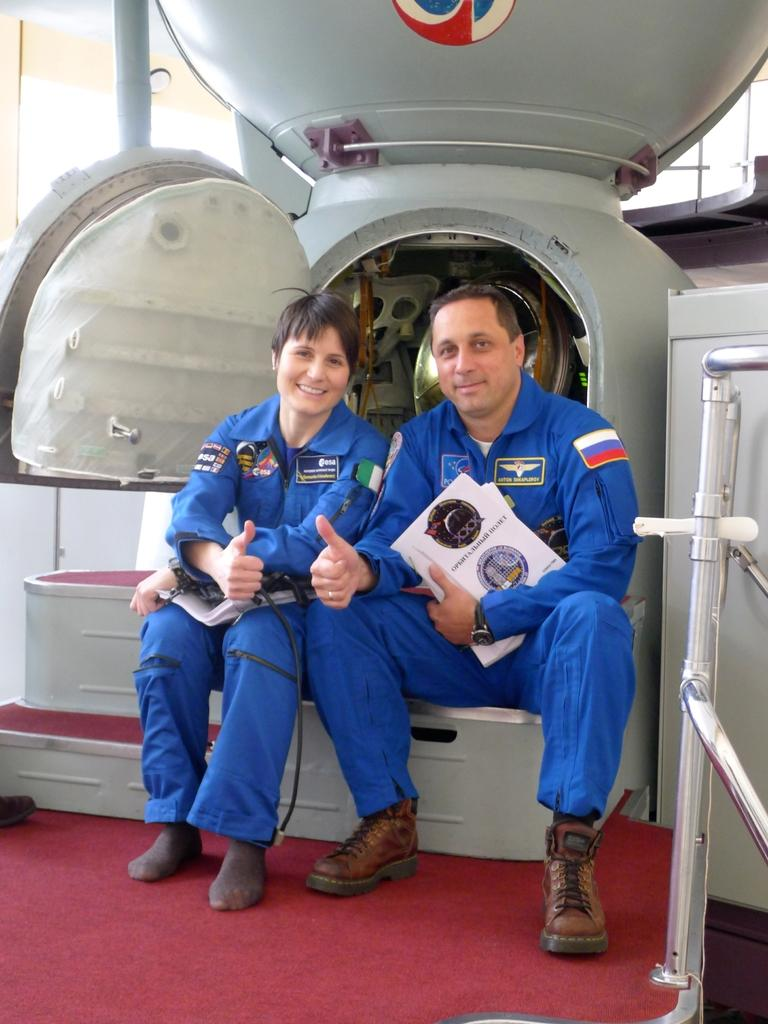How many people are in the image? There are two people in the image. What are the people doing in the image? The two people are sitting and posing for the picture, and they are giving a thumbs up gesture. What can be seen in the image besides the people? There is a machine in the image, and its door is opened. What type of guide is present in the image? There is no guide present in the image. How does the machine shake in the image? The machine does not shake in the image; it is stationary with its door opened. 